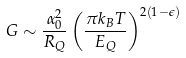<formula> <loc_0><loc_0><loc_500><loc_500>G \sim \frac { \alpha _ { 0 } ^ { 2 } } { R _ { Q } } \left ( \frac { \pi k _ { B } T } { E _ { Q } } \right ) ^ { 2 ( 1 - \epsilon ) }</formula> 